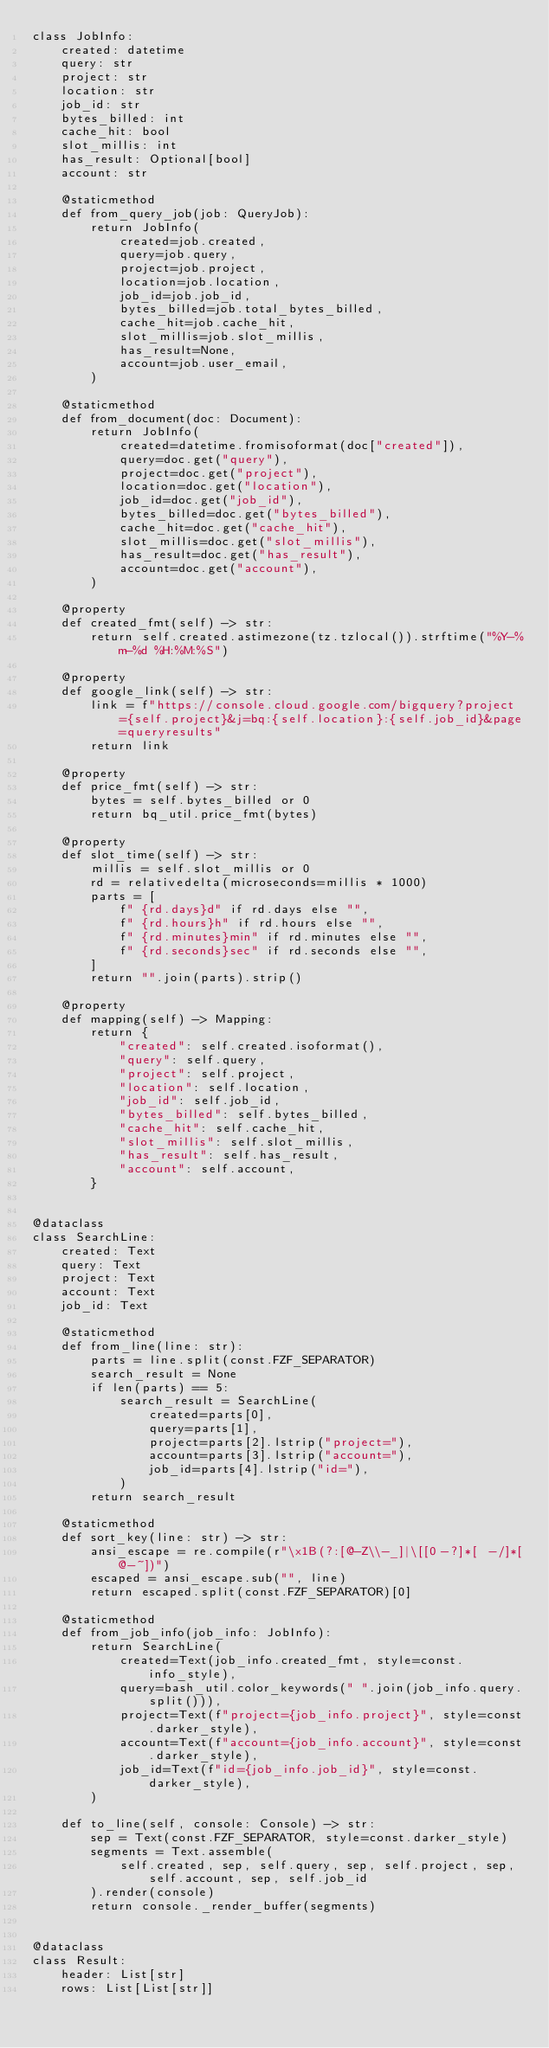<code> <loc_0><loc_0><loc_500><loc_500><_Python_>class JobInfo:
    created: datetime
    query: str
    project: str
    location: str
    job_id: str
    bytes_billed: int
    cache_hit: bool
    slot_millis: int
    has_result: Optional[bool]
    account: str

    @staticmethod
    def from_query_job(job: QueryJob):
        return JobInfo(
            created=job.created,
            query=job.query,
            project=job.project,
            location=job.location,
            job_id=job.job_id,
            bytes_billed=job.total_bytes_billed,
            cache_hit=job.cache_hit,
            slot_millis=job.slot_millis,
            has_result=None,
            account=job.user_email,
        )

    @staticmethod
    def from_document(doc: Document):
        return JobInfo(
            created=datetime.fromisoformat(doc["created"]),
            query=doc.get("query"),
            project=doc.get("project"),
            location=doc.get("location"),
            job_id=doc.get("job_id"),
            bytes_billed=doc.get("bytes_billed"),
            cache_hit=doc.get("cache_hit"),
            slot_millis=doc.get("slot_millis"),
            has_result=doc.get("has_result"),
            account=doc.get("account"),
        )

    @property
    def created_fmt(self) -> str:
        return self.created.astimezone(tz.tzlocal()).strftime("%Y-%m-%d %H:%M:%S")

    @property
    def google_link(self) -> str:
        link = f"https://console.cloud.google.com/bigquery?project={self.project}&j=bq:{self.location}:{self.job_id}&page=queryresults"
        return link

    @property
    def price_fmt(self) -> str:
        bytes = self.bytes_billed or 0
        return bq_util.price_fmt(bytes)

    @property
    def slot_time(self) -> str:
        millis = self.slot_millis or 0
        rd = relativedelta(microseconds=millis * 1000)
        parts = [
            f" {rd.days}d" if rd.days else "",
            f" {rd.hours}h" if rd.hours else "",
            f" {rd.minutes}min" if rd.minutes else "",
            f" {rd.seconds}sec" if rd.seconds else "",
        ]
        return "".join(parts).strip()

    @property
    def mapping(self) -> Mapping:
        return {
            "created": self.created.isoformat(),
            "query": self.query,
            "project": self.project,
            "location": self.location,
            "job_id": self.job_id,
            "bytes_billed": self.bytes_billed,
            "cache_hit": self.cache_hit,
            "slot_millis": self.slot_millis,
            "has_result": self.has_result,
            "account": self.account,
        }


@dataclass
class SearchLine:
    created: Text
    query: Text
    project: Text
    account: Text
    job_id: Text

    @staticmethod
    def from_line(line: str):
        parts = line.split(const.FZF_SEPARATOR)
        search_result = None
        if len(parts) == 5:
            search_result = SearchLine(
                created=parts[0],
                query=parts[1],
                project=parts[2].lstrip("project="),
                account=parts[3].lstrip("account="),
                job_id=parts[4].lstrip("id="),
            )
        return search_result

    @staticmethod
    def sort_key(line: str) -> str:
        ansi_escape = re.compile(r"\x1B(?:[@-Z\\-_]|\[[0-?]*[ -/]*[@-~])")
        escaped = ansi_escape.sub("", line)
        return escaped.split(const.FZF_SEPARATOR)[0]

    @staticmethod
    def from_job_info(job_info: JobInfo):
        return SearchLine(
            created=Text(job_info.created_fmt, style=const.info_style),
            query=bash_util.color_keywords(" ".join(job_info.query.split())),
            project=Text(f"project={job_info.project}", style=const.darker_style),
            account=Text(f"account={job_info.account}", style=const.darker_style),
            job_id=Text(f"id={job_info.job_id}", style=const.darker_style),
        )

    def to_line(self, console: Console) -> str:
        sep = Text(const.FZF_SEPARATOR, style=const.darker_style)
        segments = Text.assemble(
            self.created, sep, self.query, sep, self.project, sep, self.account, sep, self.job_id
        ).render(console)
        return console._render_buffer(segments)


@dataclass
class Result:
    header: List[str]
    rows: List[List[str]]
</code> 